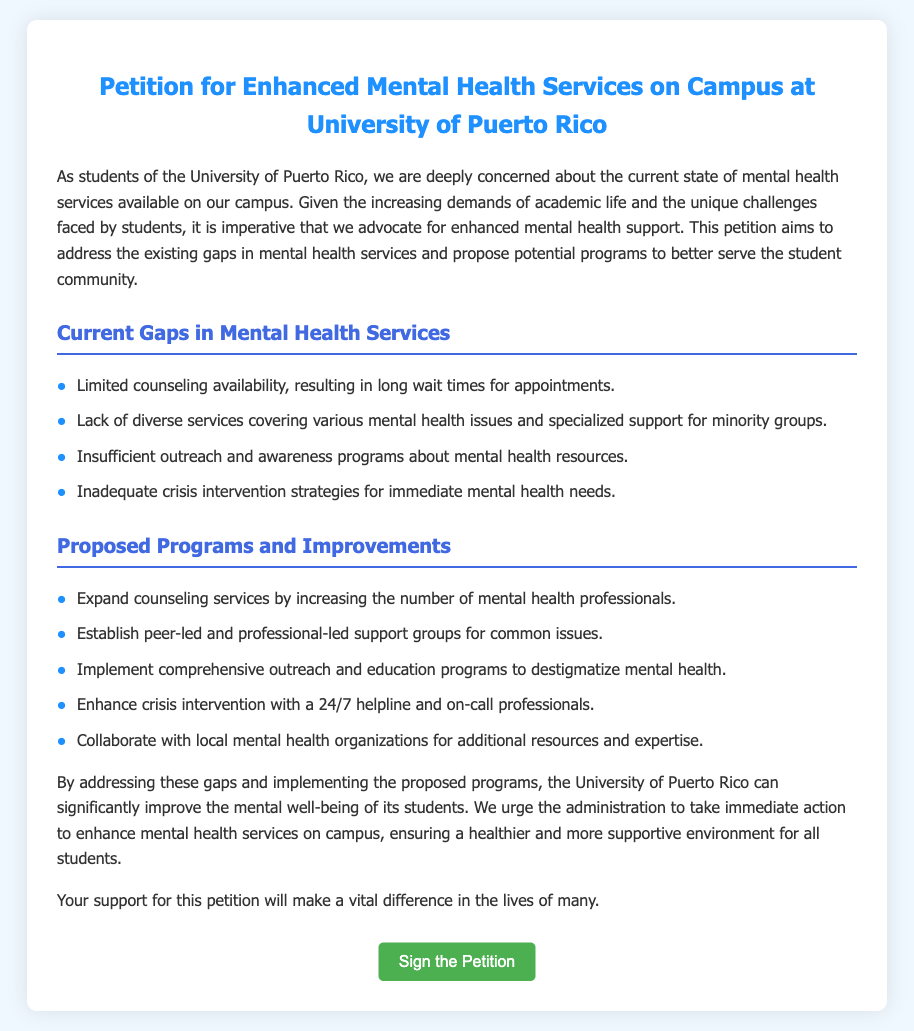What is the title of the petition? The title of the petition is clearly stated at the top of the document.
Answer: Petition for Enhanced Mental Health Services on Campus at University of Puerto Rico How many current gaps in mental health services are mentioned? The document lists specific gaps in mental health services available on campus.
Answer: Four What is one proposed program to improve mental health services? The document outlines various proposed programs to enhance mental health services.
Answer: Expand counseling services What is the color of the primary title in the document? The document describes the color used for the primary title heading.
Answer: Blue What does the petition urge the administration to do? The document specifies what the petitioners want the administration to take action on.
Answer: Take immediate action to enhance mental health services What type of professionals are suggested for the 24/7 helpline? The document specifies the type of experts needed for the crisis intervention program.
Answer: On-call professionals What is identified as a gap related to outreach? The document highlights specific issues regarding outreach in mental health services.
Answer: Insufficient outreach and awareness programs Which organization could be collaborated with for additional resources? The document mentions external organizations to collaborate with for improving mental health services.
Answer: Local mental health organizations 